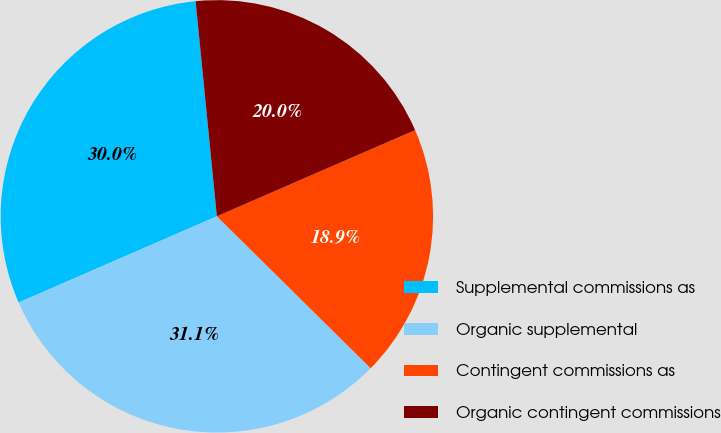<chart> <loc_0><loc_0><loc_500><loc_500><pie_chart><fcel>Supplemental commissions as<fcel>Organic supplemental<fcel>Contingent commissions as<fcel>Organic contingent commissions<nl><fcel>29.96%<fcel>31.07%<fcel>18.93%<fcel>20.04%<nl></chart> 